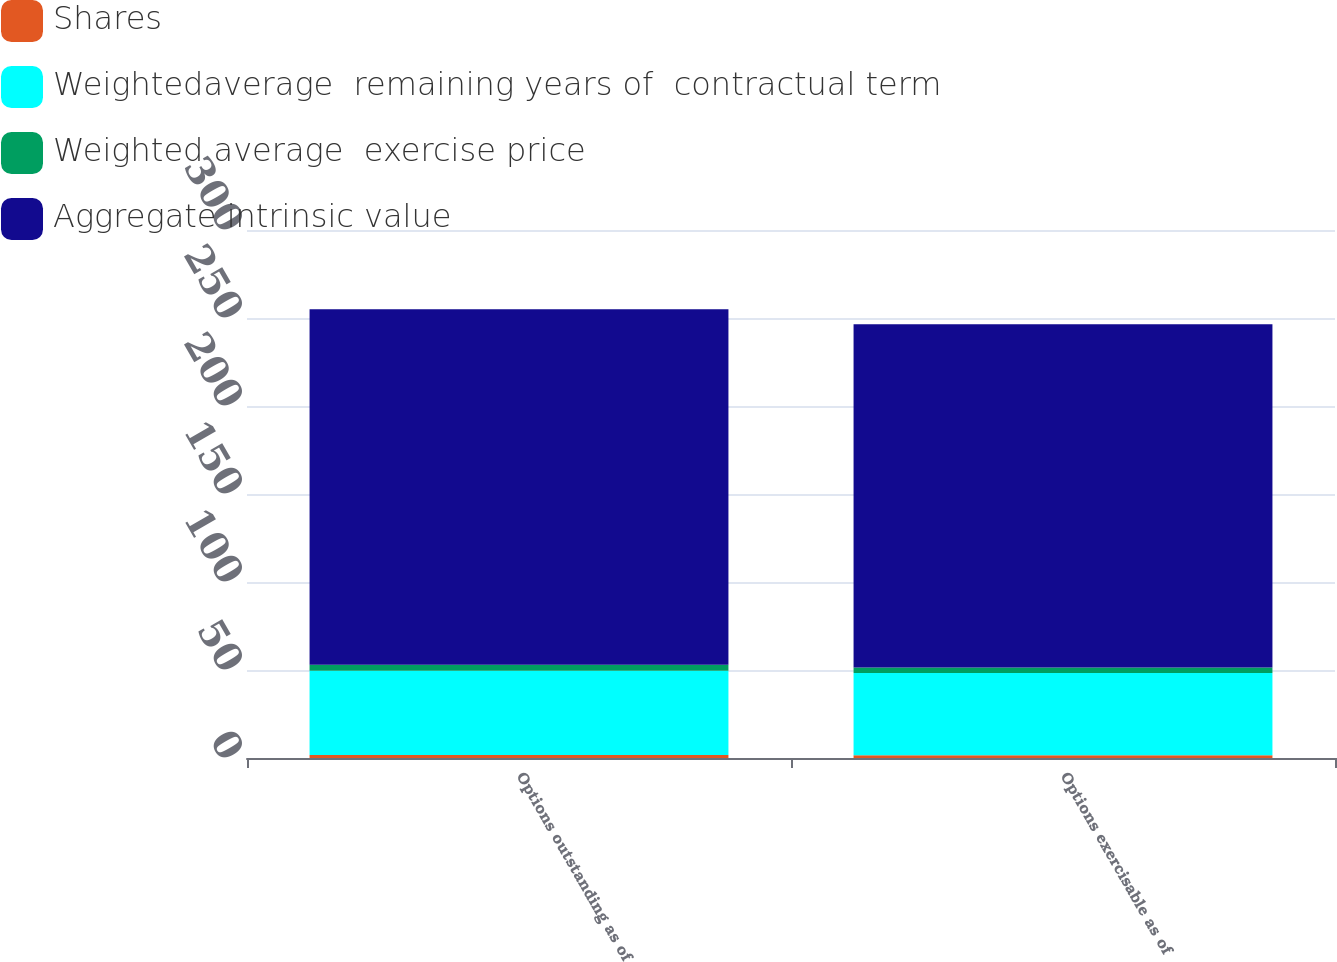Convert chart to OTSL. <chart><loc_0><loc_0><loc_500><loc_500><stacked_bar_chart><ecel><fcel>Options outstanding as of<fcel>Options exercisable as of<nl><fcel>Shares<fcel>1.7<fcel>1.6<nl><fcel>Weightedaverage  remaining years of  contractual term<fcel>47.92<fcel>46.69<nl><fcel>Weighted average  exercise price<fcel>3.3<fcel>3.1<nl><fcel>Aggregate intrinsic value<fcel>202<fcel>195<nl></chart> 